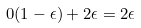<formula> <loc_0><loc_0><loc_500><loc_500>0 ( 1 - \epsilon ) + 2 \epsilon = 2 \epsilon</formula> 